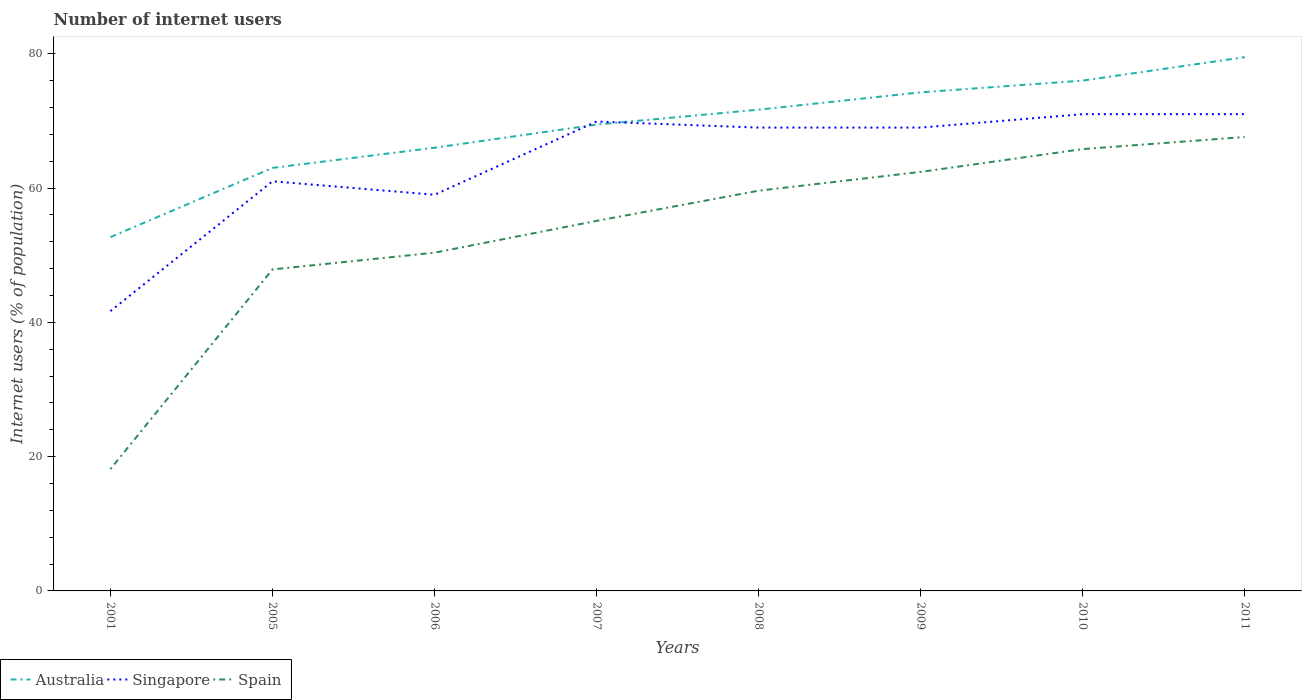How many different coloured lines are there?
Your response must be concise. 3. Does the line corresponding to Spain intersect with the line corresponding to Singapore?
Provide a short and direct response. No. Is the number of lines equal to the number of legend labels?
Provide a short and direct response. Yes. Across all years, what is the maximum number of internet users in Spain?
Provide a succinct answer. 18.15. What is the total number of internet users in Singapore in the graph?
Provide a succinct answer. 0. What is the difference between the highest and the second highest number of internet users in Singapore?
Provide a short and direct response. 29.33. What is the difference between two consecutive major ticks on the Y-axis?
Your answer should be very brief. 20. Are the values on the major ticks of Y-axis written in scientific E-notation?
Provide a short and direct response. No. Does the graph contain any zero values?
Offer a very short reply. No. How many legend labels are there?
Make the answer very short. 3. What is the title of the graph?
Make the answer very short. Number of internet users. Does "Bhutan" appear as one of the legend labels in the graph?
Make the answer very short. No. What is the label or title of the X-axis?
Ensure brevity in your answer.  Years. What is the label or title of the Y-axis?
Your answer should be very brief. Internet users (% of population). What is the Internet users (% of population) in Australia in 2001?
Provide a short and direct response. 52.69. What is the Internet users (% of population) of Singapore in 2001?
Your answer should be very brief. 41.67. What is the Internet users (% of population) of Spain in 2001?
Your answer should be compact. 18.15. What is the Internet users (% of population) of Singapore in 2005?
Provide a short and direct response. 61. What is the Internet users (% of population) of Spain in 2005?
Give a very brief answer. 47.88. What is the Internet users (% of population) of Singapore in 2006?
Offer a very short reply. 59. What is the Internet users (% of population) of Spain in 2006?
Your answer should be compact. 50.37. What is the Internet users (% of population) of Australia in 2007?
Ensure brevity in your answer.  69.45. What is the Internet users (% of population) of Singapore in 2007?
Keep it short and to the point. 69.9. What is the Internet users (% of population) of Spain in 2007?
Ensure brevity in your answer.  55.11. What is the Internet users (% of population) in Australia in 2008?
Offer a terse response. 71.67. What is the Internet users (% of population) of Spain in 2008?
Provide a succinct answer. 59.6. What is the Internet users (% of population) in Australia in 2009?
Ensure brevity in your answer.  74.25. What is the Internet users (% of population) of Spain in 2009?
Offer a very short reply. 62.4. What is the Internet users (% of population) in Singapore in 2010?
Make the answer very short. 71. What is the Internet users (% of population) in Spain in 2010?
Give a very brief answer. 65.8. What is the Internet users (% of population) in Australia in 2011?
Give a very brief answer. 79.49. What is the Internet users (% of population) in Singapore in 2011?
Offer a terse response. 71. What is the Internet users (% of population) of Spain in 2011?
Your response must be concise. 67.6. Across all years, what is the maximum Internet users (% of population) in Australia?
Keep it short and to the point. 79.49. Across all years, what is the maximum Internet users (% of population) of Spain?
Provide a short and direct response. 67.6. Across all years, what is the minimum Internet users (% of population) in Australia?
Make the answer very short. 52.69. Across all years, what is the minimum Internet users (% of population) in Singapore?
Offer a terse response. 41.67. Across all years, what is the minimum Internet users (% of population) in Spain?
Make the answer very short. 18.15. What is the total Internet users (% of population) in Australia in the graph?
Ensure brevity in your answer.  552.55. What is the total Internet users (% of population) of Singapore in the graph?
Give a very brief answer. 511.57. What is the total Internet users (% of population) in Spain in the graph?
Your answer should be very brief. 426.91. What is the difference between the Internet users (% of population) of Australia in 2001 and that in 2005?
Make the answer very short. -10.31. What is the difference between the Internet users (% of population) of Singapore in 2001 and that in 2005?
Provide a short and direct response. -19.33. What is the difference between the Internet users (% of population) in Spain in 2001 and that in 2005?
Keep it short and to the point. -29.73. What is the difference between the Internet users (% of population) in Australia in 2001 and that in 2006?
Make the answer very short. -13.31. What is the difference between the Internet users (% of population) in Singapore in 2001 and that in 2006?
Make the answer very short. -17.33. What is the difference between the Internet users (% of population) of Spain in 2001 and that in 2006?
Offer a terse response. -32.22. What is the difference between the Internet users (% of population) of Australia in 2001 and that in 2007?
Provide a succinct answer. -16.76. What is the difference between the Internet users (% of population) in Singapore in 2001 and that in 2007?
Offer a terse response. -28.23. What is the difference between the Internet users (% of population) of Spain in 2001 and that in 2007?
Provide a short and direct response. -36.96. What is the difference between the Internet users (% of population) in Australia in 2001 and that in 2008?
Give a very brief answer. -18.98. What is the difference between the Internet users (% of population) of Singapore in 2001 and that in 2008?
Offer a very short reply. -27.33. What is the difference between the Internet users (% of population) of Spain in 2001 and that in 2008?
Your answer should be very brief. -41.45. What is the difference between the Internet users (% of population) in Australia in 2001 and that in 2009?
Your answer should be very brief. -21.56. What is the difference between the Internet users (% of population) in Singapore in 2001 and that in 2009?
Your answer should be very brief. -27.33. What is the difference between the Internet users (% of population) in Spain in 2001 and that in 2009?
Make the answer very short. -44.25. What is the difference between the Internet users (% of population) in Australia in 2001 and that in 2010?
Make the answer very short. -23.31. What is the difference between the Internet users (% of population) in Singapore in 2001 and that in 2010?
Give a very brief answer. -29.33. What is the difference between the Internet users (% of population) of Spain in 2001 and that in 2010?
Provide a short and direct response. -47.65. What is the difference between the Internet users (% of population) in Australia in 2001 and that in 2011?
Your response must be concise. -26.8. What is the difference between the Internet users (% of population) in Singapore in 2001 and that in 2011?
Your answer should be very brief. -29.33. What is the difference between the Internet users (% of population) of Spain in 2001 and that in 2011?
Your answer should be very brief. -49.45. What is the difference between the Internet users (% of population) of Australia in 2005 and that in 2006?
Offer a very short reply. -3. What is the difference between the Internet users (% of population) of Singapore in 2005 and that in 2006?
Keep it short and to the point. 2. What is the difference between the Internet users (% of population) in Spain in 2005 and that in 2006?
Offer a very short reply. -2.49. What is the difference between the Internet users (% of population) in Australia in 2005 and that in 2007?
Provide a short and direct response. -6.45. What is the difference between the Internet users (% of population) in Singapore in 2005 and that in 2007?
Ensure brevity in your answer.  -8.9. What is the difference between the Internet users (% of population) of Spain in 2005 and that in 2007?
Provide a succinct answer. -7.23. What is the difference between the Internet users (% of population) of Australia in 2005 and that in 2008?
Offer a terse response. -8.67. What is the difference between the Internet users (% of population) in Singapore in 2005 and that in 2008?
Make the answer very short. -8. What is the difference between the Internet users (% of population) of Spain in 2005 and that in 2008?
Offer a terse response. -11.72. What is the difference between the Internet users (% of population) of Australia in 2005 and that in 2009?
Make the answer very short. -11.25. What is the difference between the Internet users (% of population) in Singapore in 2005 and that in 2009?
Ensure brevity in your answer.  -8. What is the difference between the Internet users (% of population) of Spain in 2005 and that in 2009?
Offer a terse response. -14.52. What is the difference between the Internet users (% of population) of Singapore in 2005 and that in 2010?
Provide a succinct answer. -10. What is the difference between the Internet users (% of population) in Spain in 2005 and that in 2010?
Ensure brevity in your answer.  -17.92. What is the difference between the Internet users (% of population) of Australia in 2005 and that in 2011?
Offer a terse response. -16.49. What is the difference between the Internet users (% of population) of Singapore in 2005 and that in 2011?
Give a very brief answer. -10. What is the difference between the Internet users (% of population) of Spain in 2005 and that in 2011?
Provide a succinct answer. -19.72. What is the difference between the Internet users (% of population) of Australia in 2006 and that in 2007?
Offer a terse response. -3.45. What is the difference between the Internet users (% of population) of Singapore in 2006 and that in 2007?
Offer a very short reply. -10.9. What is the difference between the Internet users (% of population) in Spain in 2006 and that in 2007?
Make the answer very short. -4.74. What is the difference between the Internet users (% of population) of Australia in 2006 and that in 2008?
Make the answer very short. -5.67. What is the difference between the Internet users (% of population) in Singapore in 2006 and that in 2008?
Ensure brevity in your answer.  -10. What is the difference between the Internet users (% of population) in Spain in 2006 and that in 2008?
Your answer should be very brief. -9.23. What is the difference between the Internet users (% of population) in Australia in 2006 and that in 2009?
Offer a very short reply. -8.25. What is the difference between the Internet users (% of population) in Spain in 2006 and that in 2009?
Offer a very short reply. -12.03. What is the difference between the Internet users (% of population) in Singapore in 2006 and that in 2010?
Provide a succinct answer. -12. What is the difference between the Internet users (% of population) in Spain in 2006 and that in 2010?
Your answer should be compact. -15.43. What is the difference between the Internet users (% of population) of Australia in 2006 and that in 2011?
Make the answer very short. -13.49. What is the difference between the Internet users (% of population) of Spain in 2006 and that in 2011?
Provide a succinct answer. -17.23. What is the difference between the Internet users (% of population) in Australia in 2007 and that in 2008?
Provide a succinct answer. -2.22. What is the difference between the Internet users (% of population) of Singapore in 2007 and that in 2008?
Offer a terse response. 0.9. What is the difference between the Internet users (% of population) of Spain in 2007 and that in 2008?
Ensure brevity in your answer.  -4.49. What is the difference between the Internet users (% of population) in Australia in 2007 and that in 2009?
Offer a terse response. -4.8. What is the difference between the Internet users (% of population) of Singapore in 2007 and that in 2009?
Your response must be concise. 0.9. What is the difference between the Internet users (% of population) of Spain in 2007 and that in 2009?
Give a very brief answer. -7.29. What is the difference between the Internet users (% of population) of Australia in 2007 and that in 2010?
Give a very brief answer. -6.55. What is the difference between the Internet users (% of population) in Spain in 2007 and that in 2010?
Offer a terse response. -10.69. What is the difference between the Internet users (% of population) in Australia in 2007 and that in 2011?
Keep it short and to the point. -10.04. What is the difference between the Internet users (% of population) in Spain in 2007 and that in 2011?
Keep it short and to the point. -12.49. What is the difference between the Internet users (% of population) of Australia in 2008 and that in 2009?
Make the answer very short. -2.58. What is the difference between the Internet users (% of population) of Singapore in 2008 and that in 2009?
Provide a short and direct response. 0. What is the difference between the Internet users (% of population) in Australia in 2008 and that in 2010?
Your answer should be very brief. -4.33. What is the difference between the Internet users (% of population) of Spain in 2008 and that in 2010?
Ensure brevity in your answer.  -6.2. What is the difference between the Internet users (% of population) in Australia in 2008 and that in 2011?
Provide a succinct answer. -7.82. What is the difference between the Internet users (% of population) of Australia in 2009 and that in 2010?
Offer a terse response. -1.75. What is the difference between the Internet users (% of population) in Spain in 2009 and that in 2010?
Provide a short and direct response. -3.4. What is the difference between the Internet users (% of population) of Australia in 2009 and that in 2011?
Provide a succinct answer. -5.24. What is the difference between the Internet users (% of population) of Singapore in 2009 and that in 2011?
Your answer should be very brief. -2. What is the difference between the Internet users (% of population) of Spain in 2009 and that in 2011?
Offer a terse response. -5.2. What is the difference between the Internet users (% of population) in Australia in 2010 and that in 2011?
Ensure brevity in your answer.  -3.49. What is the difference between the Internet users (% of population) of Singapore in 2010 and that in 2011?
Make the answer very short. 0. What is the difference between the Internet users (% of population) of Australia in 2001 and the Internet users (% of population) of Singapore in 2005?
Offer a terse response. -8.31. What is the difference between the Internet users (% of population) in Australia in 2001 and the Internet users (% of population) in Spain in 2005?
Your response must be concise. 4.81. What is the difference between the Internet users (% of population) in Singapore in 2001 and the Internet users (% of population) in Spain in 2005?
Offer a very short reply. -6.21. What is the difference between the Internet users (% of population) in Australia in 2001 and the Internet users (% of population) in Singapore in 2006?
Keep it short and to the point. -6.31. What is the difference between the Internet users (% of population) in Australia in 2001 and the Internet users (% of population) in Spain in 2006?
Give a very brief answer. 2.32. What is the difference between the Internet users (% of population) of Singapore in 2001 and the Internet users (% of population) of Spain in 2006?
Provide a short and direct response. -8.7. What is the difference between the Internet users (% of population) in Australia in 2001 and the Internet users (% of population) in Singapore in 2007?
Provide a succinct answer. -17.21. What is the difference between the Internet users (% of population) of Australia in 2001 and the Internet users (% of population) of Spain in 2007?
Your answer should be very brief. -2.42. What is the difference between the Internet users (% of population) in Singapore in 2001 and the Internet users (% of population) in Spain in 2007?
Make the answer very short. -13.44. What is the difference between the Internet users (% of population) of Australia in 2001 and the Internet users (% of population) of Singapore in 2008?
Offer a terse response. -16.31. What is the difference between the Internet users (% of population) of Australia in 2001 and the Internet users (% of population) of Spain in 2008?
Your response must be concise. -6.91. What is the difference between the Internet users (% of population) in Singapore in 2001 and the Internet users (% of population) in Spain in 2008?
Give a very brief answer. -17.93. What is the difference between the Internet users (% of population) in Australia in 2001 and the Internet users (% of population) in Singapore in 2009?
Offer a terse response. -16.31. What is the difference between the Internet users (% of population) in Australia in 2001 and the Internet users (% of population) in Spain in 2009?
Provide a short and direct response. -9.71. What is the difference between the Internet users (% of population) in Singapore in 2001 and the Internet users (% of population) in Spain in 2009?
Ensure brevity in your answer.  -20.73. What is the difference between the Internet users (% of population) in Australia in 2001 and the Internet users (% of population) in Singapore in 2010?
Ensure brevity in your answer.  -18.31. What is the difference between the Internet users (% of population) in Australia in 2001 and the Internet users (% of population) in Spain in 2010?
Make the answer very short. -13.11. What is the difference between the Internet users (% of population) of Singapore in 2001 and the Internet users (% of population) of Spain in 2010?
Offer a very short reply. -24.13. What is the difference between the Internet users (% of population) in Australia in 2001 and the Internet users (% of population) in Singapore in 2011?
Provide a succinct answer. -18.31. What is the difference between the Internet users (% of population) in Australia in 2001 and the Internet users (% of population) in Spain in 2011?
Ensure brevity in your answer.  -14.91. What is the difference between the Internet users (% of population) of Singapore in 2001 and the Internet users (% of population) of Spain in 2011?
Ensure brevity in your answer.  -25.93. What is the difference between the Internet users (% of population) of Australia in 2005 and the Internet users (% of population) of Spain in 2006?
Your answer should be very brief. 12.63. What is the difference between the Internet users (% of population) of Singapore in 2005 and the Internet users (% of population) of Spain in 2006?
Offer a terse response. 10.63. What is the difference between the Internet users (% of population) in Australia in 2005 and the Internet users (% of population) in Singapore in 2007?
Your answer should be compact. -6.9. What is the difference between the Internet users (% of population) of Australia in 2005 and the Internet users (% of population) of Spain in 2007?
Make the answer very short. 7.89. What is the difference between the Internet users (% of population) of Singapore in 2005 and the Internet users (% of population) of Spain in 2007?
Keep it short and to the point. 5.89. What is the difference between the Internet users (% of population) in Australia in 2005 and the Internet users (% of population) in Singapore in 2008?
Ensure brevity in your answer.  -6. What is the difference between the Internet users (% of population) of Singapore in 2005 and the Internet users (% of population) of Spain in 2008?
Keep it short and to the point. 1.4. What is the difference between the Internet users (% of population) in Australia in 2005 and the Internet users (% of population) in Spain in 2009?
Your answer should be very brief. 0.6. What is the difference between the Internet users (% of population) in Singapore in 2005 and the Internet users (% of population) in Spain in 2010?
Offer a terse response. -4.8. What is the difference between the Internet users (% of population) of Australia in 2006 and the Internet users (% of population) of Singapore in 2007?
Make the answer very short. -3.9. What is the difference between the Internet users (% of population) of Australia in 2006 and the Internet users (% of population) of Spain in 2007?
Give a very brief answer. 10.89. What is the difference between the Internet users (% of population) in Singapore in 2006 and the Internet users (% of population) in Spain in 2007?
Your answer should be very brief. 3.89. What is the difference between the Internet users (% of population) of Australia in 2006 and the Internet users (% of population) of Singapore in 2009?
Provide a succinct answer. -3. What is the difference between the Internet users (% of population) of Australia in 2006 and the Internet users (% of population) of Spain in 2009?
Provide a succinct answer. 3.6. What is the difference between the Internet users (% of population) in Singapore in 2006 and the Internet users (% of population) in Spain in 2009?
Your response must be concise. -3.4. What is the difference between the Internet users (% of population) of Australia in 2006 and the Internet users (% of population) of Spain in 2010?
Keep it short and to the point. 0.2. What is the difference between the Internet users (% of population) of Australia in 2006 and the Internet users (% of population) of Singapore in 2011?
Offer a terse response. -5. What is the difference between the Internet users (% of population) in Australia in 2006 and the Internet users (% of population) in Spain in 2011?
Ensure brevity in your answer.  -1.6. What is the difference between the Internet users (% of population) of Singapore in 2006 and the Internet users (% of population) of Spain in 2011?
Provide a short and direct response. -8.6. What is the difference between the Internet users (% of population) in Australia in 2007 and the Internet users (% of population) in Singapore in 2008?
Offer a terse response. 0.45. What is the difference between the Internet users (% of population) of Australia in 2007 and the Internet users (% of population) of Spain in 2008?
Your response must be concise. 9.85. What is the difference between the Internet users (% of population) of Singapore in 2007 and the Internet users (% of population) of Spain in 2008?
Your answer should be compact. 10.3. What is the difference between the Internet users (% of population) in Australia in 2007 and the Internet users (% of population) in Singapore in 2009?
Offer a very short reply. 0.45. What is the difference between the Internet users (% of population) of Australia in 2007 and the Internet users (% of population) of Spain in 2009?
Provide a short and direct response. 7.05. What is the difference between the Internet users (% of population) of Singapore in 2007 and the Internet users (% of population) of Spain in 2009?
Ensure brevity in your answer.  7.5. What is the difference between the Internet users (% of population) of Australia in 2007 and the Internet users (% of population) of Singapore in 2010?
Keep it short and to the point. -1.55. What is the difference between the Internet users (% of population) in Australia in 2007 and the Internet users (% of population) in Spain in 2010?
Make the answer very short. 3.65. What is the difference between the Internet users (% of population) in Australia in 2007 and the Internet users (% of population) in Singapore in 2011?
Provide a succinct answer. -1.55. What is the difference between the Internet users (% of population) in Australia in 2007 and the Internet users (% of population) in Spain in 2011?
Offer a terse response. 1.85. What is the difference between the Internet users (% of population) in Australia in 2008 and the Internet users (% of population) in Singapore in 2009?
Ensure brevity in your answer.  2.67. What is the difference between the Internet users (% of population) of Australia in 2008 and the Internet users (% of population) of Spain in 2009?
Your response must be concise. 9.27. What is the difference between the Internet users (% of population) of Australia in 2008 and the Internet users (% of population) of Singapore in 2010?
Provide a short and direct response. 0.67. What is the difference between the Internet users (% of population) in Australia in 2008 and the Internet users (% of population) in Spain in 2010?
Ensure brevity in your answer.  5.87. What is the difference between the Internet users (% of population) in Australia in 2008 and the Internet users (% of population) in Singapore in 2011?
Your answer should be very brief. 0.67. What is the difference between the Internet users (% of population) of Australia in 2008 and the Internet users (% of population) of Spain in 2011?
Offer a terse response. 4.07. What is the difference between the Internet users (% of population) in Australia in 2009 and the Internet users (% of population) in Spain in 2010?
Your answer should be compact. 8.45. What is the difference between the Internet users (% of population) of Australia in 2009 and the Internet users (% of population) of Spain in 2011?
Make the answer very short. 6.65. What is the difference between the Internet users (% of population) of Singapore in 2009 and the Internet users (% of population) of Spain in 2011?
Your answer should be very brief. 1.4. What is the average Internet users (% of population) in Australia per year?
Ensure brevity in your answer.  69.07. What is the average Internet users (% of population) of Singapore per year?
Offer a terse response. 63.95. What is the average Internet users (% of population) in Spain per year?
Your response must be concise. 53.36. In the year 2001, what is the difference between the Internet users (% of population) in Australia and Internet users (% of population) in Singapore?
Your answer should be very brief. 11.02. In the year 2001, what is the difference between the Internet users (% of population) in Australia and Internet users (% of population) in Spain?
Offer a very short reply. 34.54. In the year 2001, what is the difference between the Internet users (% of population) of Singapore and Internet users (% of population) of Spain?
Offer a very short reply. 23.52. In the year 2005, what is the difference between the Internet users (% of population) in Australia and Internet users (% of population) in Singapore?
Your response must be concise. 2. In the year 2005, what is the difference between the Internet users (% of population) in Australia and Internet users (% of population) in Spain?
Keep it short and to the point. 15.12. In the year 2005, what is the difference between the Internet users (% of population) of Singapore and Internet users (% of population) of Spain?
Offer a very short reply. 13.12. In the year 2006, what is the difference between the Internet users (% of population) in Australia and Internet users (% of population) in Singapore?
Your response must be concise. 7. In the year 2006, what is the difference between the Internet users (% of population) in Australia and Internet users (% of population) in Spain?
Your response must be concise. 15.63. In the year 2006, what is the difference between the Internet users (% of population) of Singapore and Internet users (% of population) of Spain?
Your answer should be very brief. 8.63. In the year 2007, what is the difference between the Internet users (% of population) of Australia and Internet users (% of population) of Singapore?
Provide a succinct answer. -0.45. In the year 2007, what is the difference between the Internet users (% of population) of Australia and Internet users (% of population) of Spain?
Make the answer very short. 14.34. In the year 2007, what is the difference between the Internet users (% of population) in Singapore and Internet users (% of population) in Spain?
Your answer should be very brief. 14.79. In the year 2008, what is the difference between the Internet users (% of population) in Australia and Internet users (% of population) in Singapore?
Your response must be concise. 2.67. In the year 2008, what is the difference between the Internet users (% of population) in Australia and Internet users (% of population) in Spain?
Keep it short and to the point. 12.07. In the year 2008, what is the difference between the Internet users (% of population) of Singapore and Internet users (% of population) of Spain?
Keep it short and to the point. 9.4. In the year 2009, what is the difference between the Internet users (% of population) of Australia and Internet users (% of population) of Singapore?
Provide a short and direct response. 5.25. In the year 2009, what is the difference between the Internet users (% of population) in Australia and Internet users (% of population) in Spain?
Offer a terse response. 11.85. In the year 2009, what is the difference between the Internet users (% of population) of Singapore and Internet users (% of population) of Spain?
Your response must be concise. 6.6. In the year 2011, what is the difference between the Internet users (% of population) in Australia and Internet users (% of population) in Singapore?
Give a very brief answer. 8.49. In the year 2011, what is the difference between the Internet users (% of population) of Australia and Internet users (% of population) of Spain?
Keep it short and to the point. 11.89. What is the ratio of the Internet users (% of population) of Australia in 2001 to that in 2005?
Ensure brevity in your answer.  0.84. What is the ratio of the Internet users (% of population) of Singapore in 2001 to that in 2005?
Your answer should be very brief. 0.68. What is the ratio of the Internet users (% of population) in Spain in 2001 to that in 2005?
Your response must be concise. 0.38. What is the ratio of the Internet users (% of population) of Australia in 2001 to that in 2006?
Give a very brief answer. 0.8. What is the ratio of the Internet users (% of population) in Singapore in 2001 to that in 2006?
Your response must be concise. 0.71. What is the ratio of the Internet users (% of population) in Spain in 2001 to that in 2006?
Offer a very short reply. 0.36. What is the ratio of the Internet users (% of population) of Australia in 2001 to that in 2007?
Your response must be concise. 0.76. What is the ratio of the Internet users (% of population) in Singapore in 2001 to that in 2007?
Provide a succinct answer. 0.6. What is the ratio of the Internet users (% of population) of Spain in 2001 to that in 2007?
Your answer should be very brief. 0.33. What is the ratio of the Internet users (% of population) in Australia in 2001 to that in 2008?
Provide a short and direct response. 0.74. What is the ratio of the Internet users (% of population) of Singapore in 2001 to that in 2008?
Your response must be concise. 0.6. What is the ratio of the Internet users (% of population) of Spain in 2001 to that in 2008?
Keep it short and to the point. 0.3. What is the ratio of the Internet users (% of population) of Australia in 2001 to that in 2009?
Make the answer very short. 0.71. What is the ratio of the Internet users (% of population) in Singapore in 2001 to that in 2009?
Ensure brevity in your answer.  0.6. What is the ratio of the Internet users (% of population) of Spain in 2001 to that in 2009?
Make the answer very short. 0.29. What is the ratio of the Internet users (% of population) of Australia in 2001 to that in 2010?
Your response must be concise. 0.69. What is the ratio of the Internet users (% of population) in Singapore in 2001 to that in 2010?
Keep it short and to the point. 0.59. What is the ratio of the Internet users (% of population) of Spain in 2001 to that in 2010?
Give a very brief answer. 0.28. What is the ratio of the Internet users (% of population) in Australia in 2001 to that in 2011?
Your response must be concise. 0.66. What is the ratio of the Internet users (% of population) of Singapore in 2001 to that in 2011?
Your answer should be compact. 0.59. What is the ratio of the Internet users (% of population) of Spain in 2001 to that in 2011?
Your response must be concise. 0.27. What is the ratio of the Internet users (% of population) in Australia in 2005 to that in 2006?
Provide a succinct answer. 0.95. What is the ratio of the Internet users (% of population) in Singapore in 2005 to that in 2006?
Ensure brevity in your answer.  1.03. What is the ratio of the Internet users (% of population) of Spain in 2005 to that in 2006?
Your response must be concise. 0.95. What is the ratio of the Internet users (% of population) in Australia in 2005 to that in 2007?
Make the answer very short. 0.91. What is the ratio of the Internet users (% of population) of Singapore in 2005 to that in 2007?
Make the answer very short. 0.87. What is the ratio of the Internet users (% of population) of Spain in 2005 to that in 2007?
Offer a terse response. 0.87. What is the ratio of the Internet users (% of population) in Australia in 2005 to that in 2008?
Provide a succinct answer. 0.88. What is the ratio of the Internet users (% of population) of Singapore in 2005 to that in 2008?
Give a very brief answer. 0.88. What is the ratio of the Internet users (% of population) of Spain in 2005 to that in 2008?
Make the answer very short. 0.8. What is the ratio of the Internet users (% of population) of Australia in 2005 to that in 2009?
Ensure brevity in your answer.  0.85. What is the ratio of the Internet users (% of population) in Singapore in 2005 to that in 2009?
Keep it short and to the point. 0.88. What is the ratio of the Internet users (% of population) in Spain in 2005 to that in 2009?
Your answer should be very brief. 0.77. What is the ratio of the Internet users (% of population) in Australia in 2005 to that in 2010?
Offer a very short reply. 0.83. What is the ratio of the Internet users (% of population) in Singapore in 2005 to that in 2010?
Give a very brief answer. 0.86. What is the ratio of the Internet users (% of population) in Spain in 2005 to that in 2010?
Ensure brevity in your answer.  0.73. What is the ratio of the Internet users (% of population) in Australia in 2005 to that in 2011?
Provide a succinct answer. 0.79. What is the ratio of the Internet users (% of population) in Singapore in 2005 to that in 2011?
Ensure brevity in your answer.  0.86. What is the ratio of the Internet users (% of population) in Spain in 2005 to that in 2011?
Offer a very short reply. 0.71. What is the ratio of the Internet users (% of population) of Australia in 2006 to that in 2007?
Make the answer very short. 0.95. What is the ratio of the Internet users (% of population) in Singapore in 2006 to that in 2007?
Make the answer very short. 0.84. What is the ratio of the Internet users (% of population) in Spain in 2006 to that in 2007?
Offer a terse response. 0.91. What is the ratio of the Internet users (% of population) in Australia in 2006 to that in 2008?
Provide a succinct answer. 0.92. What is the ratio of the Internet users (% of population) of Singapore in 2006 to that in 2008?
Ensure brevity in your answer.  0.86. What is the ratio of the Internet users (% of population) of Spain in 2006 to that in 2008?
Keep it short and to the point. 0.85. What is the ratio of the Internet users (% of population) in Singapore in 2006 to that in 2009?
Provide a succinct answer. 0.86. What is the ratio of the Internet users (% of population) of Spain in 2006 to that in 2009?
Ensure brevity in your answer.  0.81. What is the ratio of the Internet users (% of population) of Australia in 2006 to that in 2010?
Give a very brief answer. 0.87. What is the ratio of the Internet users (% of population) of Singapore in 2006 to that in 2010?
Make the answer very short. 0.83. What is the ratio of the Internet users (% of population) in Spain in 2006 to that in 2010?
Provide a succinct answer. 0.77. What is the ratio of the Internet users (% of population) of Australia in 2006 to that in 2011?
Provide a short and direct response. 0.83. What is the ratio of the Internet users (% of population) in Singapore in 2006 to that in 2011?
Keep it short and to the point. 0.83. What is the ratio of the Internet users (% of population) in Spain in 2006 to that in 2011?
Offer a terse response. 0.75. What is the ratio of the Internet users (% of population) in Australia in 2007 to that in 2008?
Your answer should be very brief. 0.97. What is the ratio of the Internet users (% of population) of Singapore in 2007 to that in 2008?
Provide a short and direct response. 1.01. What is the ratio of the Internet users (% of population) in Spain in 2007 to that in 2008?
Your answer should be very brief. 0.92. What is the ratio of the Internet users (% of population) of Australia in 2007 to that in 2009?
Ensure brevity in your answer.  0.94. What is the ratio of the Internet users (% of population) of Spain in 2007 to that in 2009?
Your response must be concise. 0.88. What is the ratio of the Internet users (% of population) in Australia in 2007 to that in 2010?
Keep it short and to the point. 0.91. What is the ratio of the Internet users (% of population) in Singapore in 2007 to that in 2010?
Your answer should be very brief. 0.98. What is the ratio of the Internet users (% of population) in Spain in 2007 to that in 2010?
Give a very brief answer. 0.84. What is the ratio of the Internet users (% of population) in Australia in 2007 to that in 2011?
Give a very brief answer. 0.87. What is the ratio of the Internet users (% of population) in Singapore in 2007 to that in 2011?
Your answer should be compact. 0.98. What is the ratio of the Internet users (% of population) of Spain in 2007 to that in 2011?
Your response must be concise. 0.82. What is the ratio of the Internet users (% of population) in Australia in 2008 to that in 2009?
Provide a short and direct response. 0.97. What is the ratio of the Internet users (% of population) of Singapore in 2008 to that in 2009?
Offer a terse response. 1. What is the ratio of the Internet users (% of population) of Spain in 2008 to that in 2009?
Offer a very short reply. 0.96. What is the ratio of the Internet users (% of population) of Australia in 2008 to that in 2010?
Make the answer very short. 0.94. What is the ratio of the Internet users (% of population) in Singapore in 2008 to that in 2010?
Keep it short and to the point. 0.97. What is the ratio of the Internet users (% of population) in Spain in 2008 to that in 2010?
Provide a short and direct response. 0.91. What is the ratio of the Internet users (% of population) in Australia in 2008 to that in 2011?
Provide a short and direct response. 0.9. What is the ratio of the Internet users (% of population) of Singapore in 2008 to that in 2011?
Your response must be concise. 0.97. What is the ratio of the Internet users (% of population) of Spain in 2008 to that in 2011?
Ensure brevity in your answer.  0.88. What is the ratio of the Internet users (% of population) of Singapore in 2009 to that in 2010?
Keep it short and to the point. 0.97. What is the ratio of the Internet users (% of population) of Spain in 2009 to that in 2010?
Your answer should be very brief. 0.95. What is the ratio of the Internet users (% of population) of Australia in 2009 to that in 2011?
Give a very brief answer. 0.93. What is the ratio of the Internet users (% of population) in Singapore in 2009 to that in 2011?
Provide a short and direct response. 0.97. What is the ratio of the Internet users (% of population) of Spain in 2009 to that in 2011?
Your answer should be compact. 0.92. What is the ratio of the Internet users (% of population) of Australia in 2010 to that in 2011?
Give a very brief answer. 0.96. What is the ratio of the Internet users (% of population) of Singapore in 2010 to that in 2011?
Your answer should be very brief. 1. What is the ratio of the Internet users (% of population) in Spain in 2010 to that in 2011?
Your answer should be compact. 0.97. What is the difference between the highest and the second highest Internet users (% of population) in Australia?
Give a very brief answer. 3.49. What is the difference between the highest and the second highest Internet users (% of population) of Singapore?
Your answer should be very brief. 0. What is the difference between the highest and the lowest Internet users (% of population) in Australia?
Your answer should be very brief. 26.8. What is the difference between the highest and the lowest Internet users (% of population) of Singapore?
Make the answer very short. 29.33. What is the difference between the highest and the lowest Internet users (% of population) of Spain?
Provide a succinct answer. 49.45. 